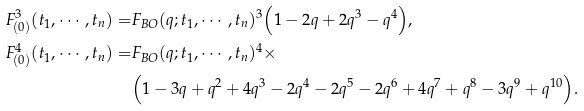<formula> <loc_0><loc_0><loc_500><loc_500>F ^ { 3 } _ { ( 0 ) } ( t _ { 1 } , \cdots , t _ { n } ) = & F _ { B O } ( q ; t _ { 1 } , \cdots , t _ { n } ) ^ { 3 } \Big { ( } 1 - 2 q + 2 q ^ { 3 } - q ^ { 4 } \Big { ) } , \\ F ^ { 4 } _ { ( 0 ) } ( t _ { 1 } , \cdots , t _ { n } ) = & F _ { B O } ( q ; t _ { 1 } , \cdots , t _ { n } ) ^ { 4 } \times \\ & \Big { ( } 1 - 3 q + q ^ { 2 } + 4 q ^ { 3 } - 2 q ^ { 4 } - 2 q ^ { 5 } - 2 q ^ { 6 } + 4 q ^ { 7 } + q ^ { 8 } - 3 q ^ { 9 } + q ^ { 1 0 } \Big { ) } .</formula> 